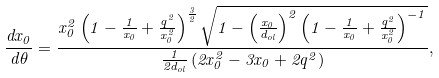<formula> <loc_0><loc_0><loc_500><loc_500>\frac { d x _ { 0 } } { d \theta } = \frac { x _ { 0 } ^ { 2 } \left ( 1 - \frac { 1 } { x _ { 0 } } + \frac { q ^ { 2 } } { x _ { 0 } ^ { 2 } } \right ) ^ { \frac { 3 } { 2 } } \sqrt { 1 - \left ( \frac { x _ { 0 } } { d _ { o l } } \right ) ^ { 2 } \left ( 1 - \frac { 1 } { x _ { 0 } } + \frac { q ^ { 2 } } { x _ { 0 } ^ { 2 } } \right ) ^ { - 1 } } } { \frac { 1 } { 2 d _ { o l } } \left ( 2 x _ { 0 } ^ { 2 } - 3 x _ { 0 } + 2 q ^ { 2 } \right ) } ,</formula> 